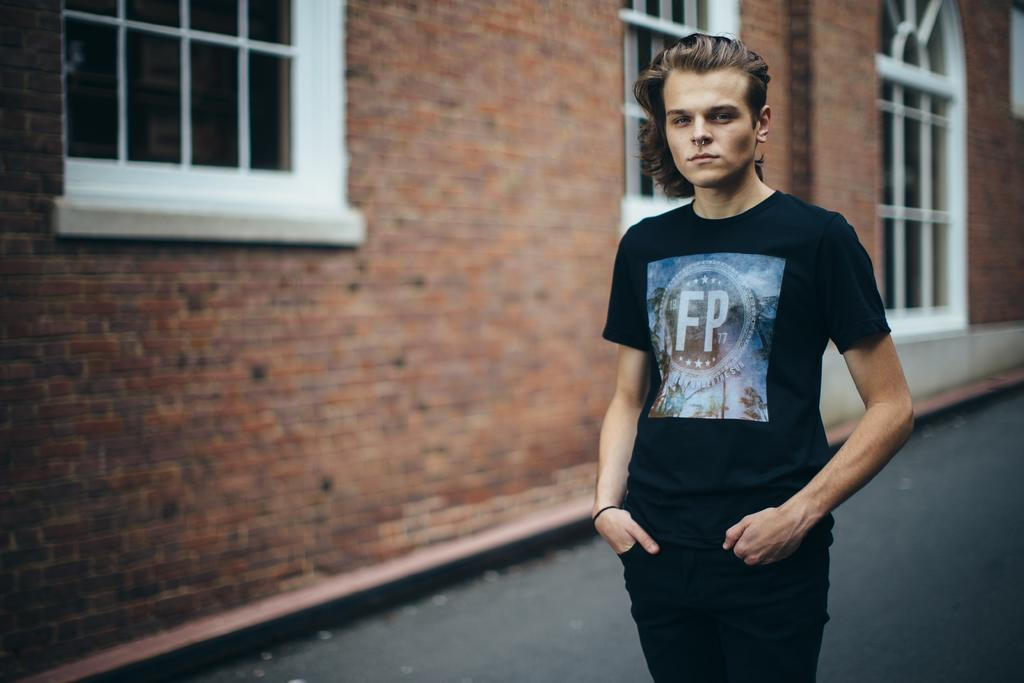What is the main subject of the image? There is a person in the image. Can you describe the background of the image? There is a wall with glass windows in the image. What type of fruit is the person holding in the image? There is no fruit present in the image. What is the person writing on the wall in the image? The person is not writing on the wall in the image. 